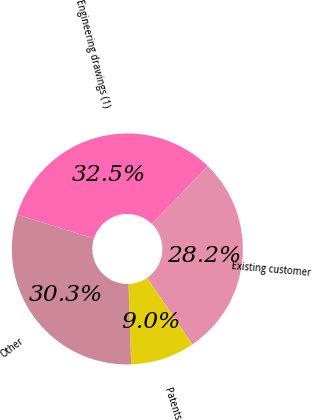Convert chart to OTSL. <chart><loc_0><loc_0><loc_500><loc_500><pie_chart><fcel>Engineering drawings (1)<fcel>Existing customer<fcel>Patents<fcel>Other<nl><fcel>32.46%<fcel>28.21%<fcel>8.99%<fcel>30.34%<nl></chart> 